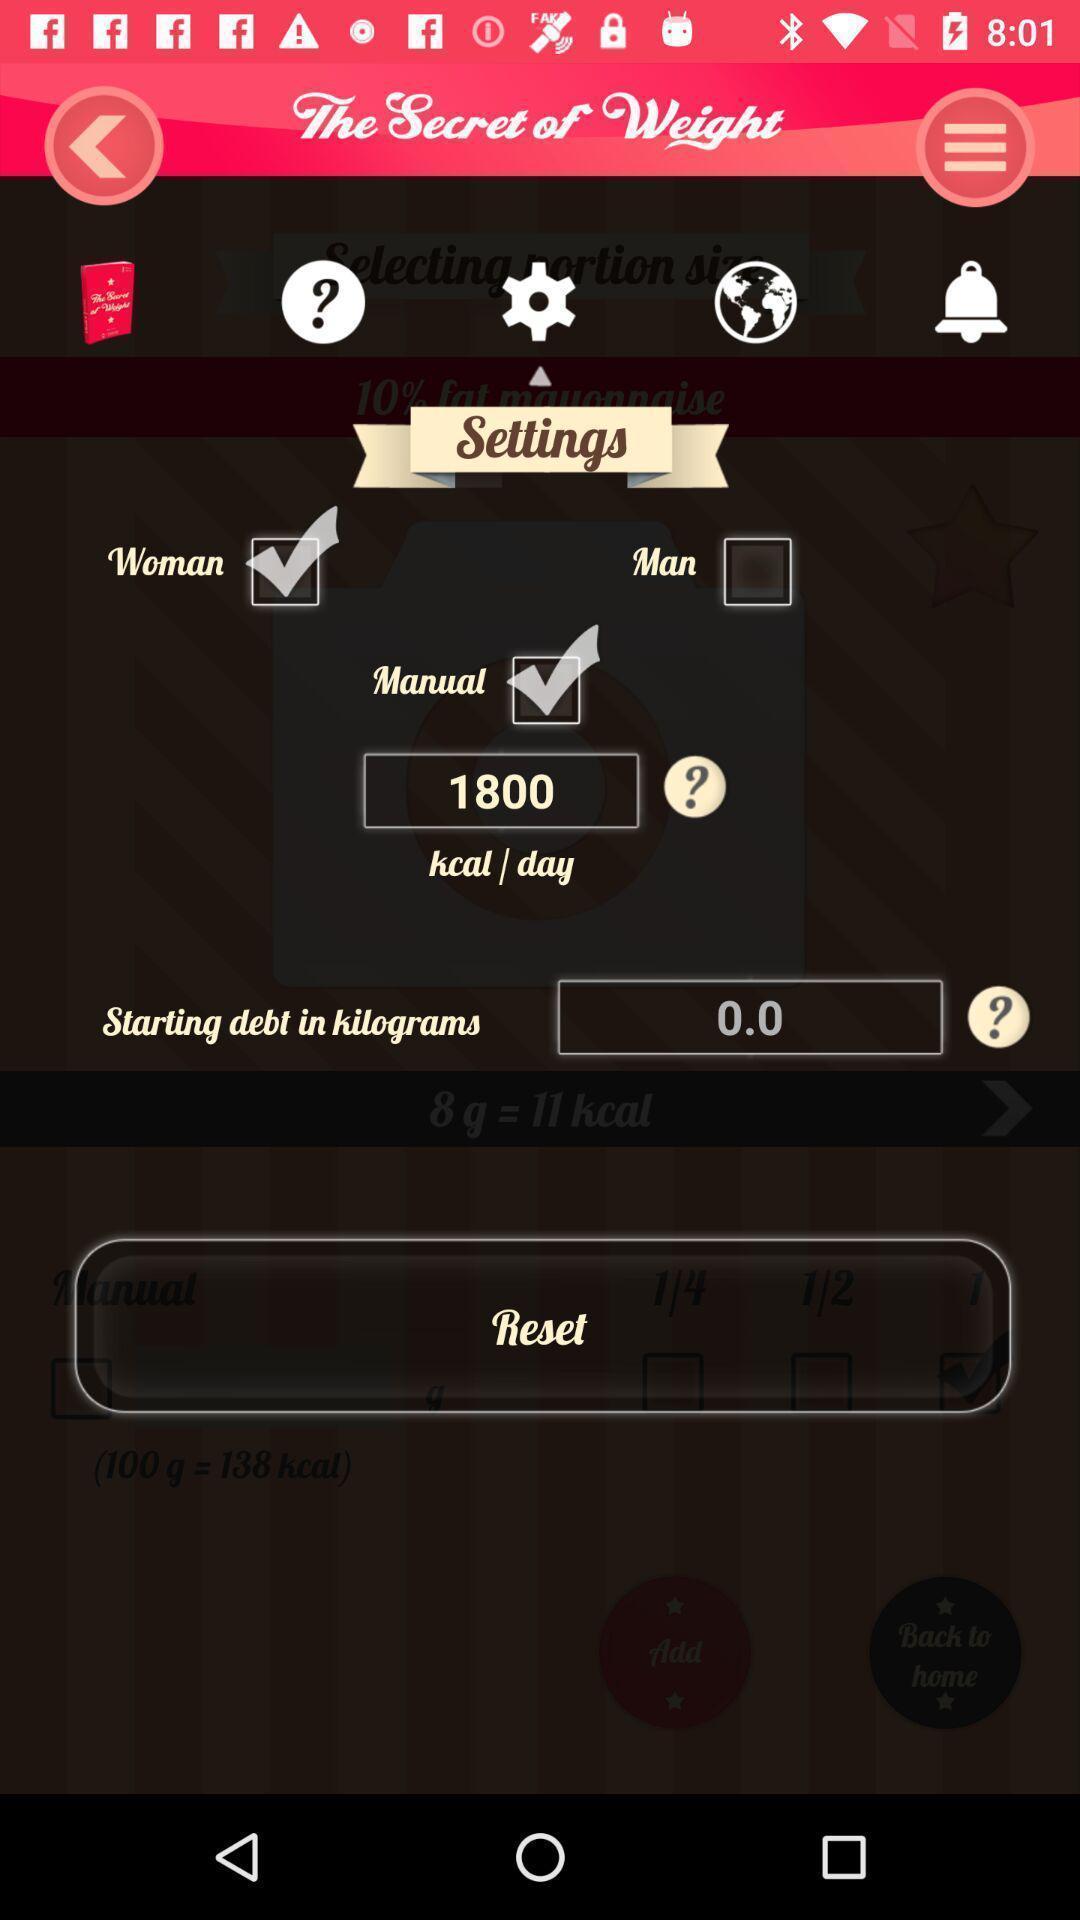Describe this image in words. Settings page of a weight managing app. 